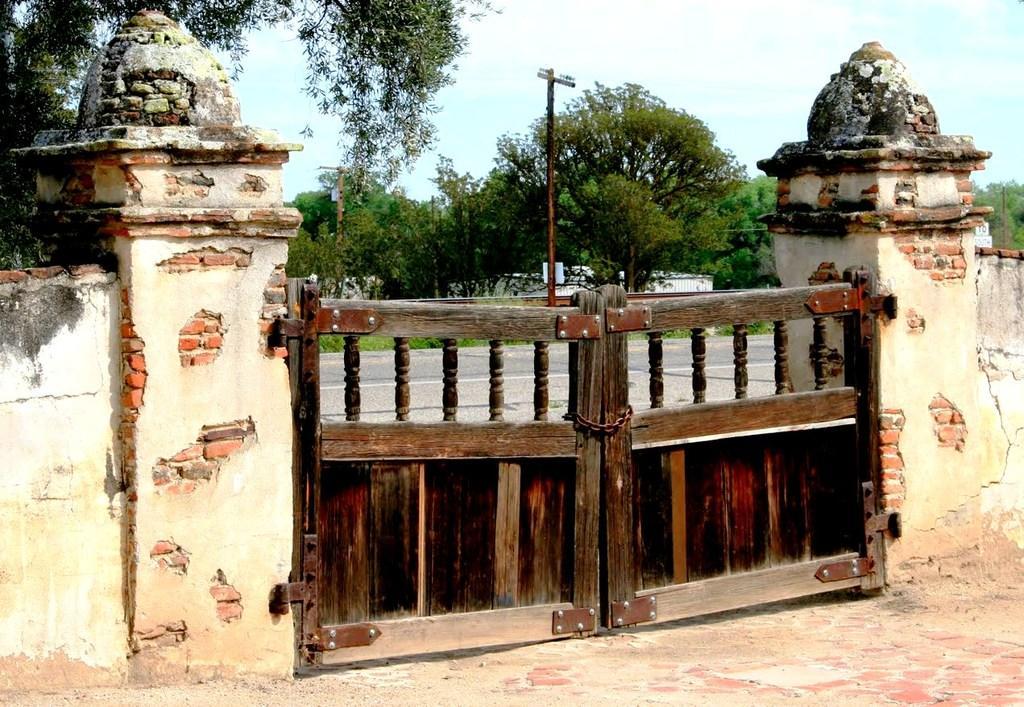In one or two sentences, can you explain what this image depicts? In this image we can see gate and walls. In the background we can see poles, trees, houses and clouds in the sky. 